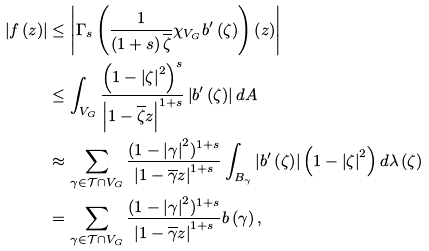<formula> <loc_0><loc_0><loc_500><loc_500>\left | f \left ( z \right ) \right | & \leq \left | \Gamma _ { s } \left ( \frac { 1 } { \left ( 1 + s \right ) \overline { \zeta } } \chi _ { V _ { G } } b ^ { \prime } \left ( \zeta \right ) \right ) \left ( z \right ) \right | \\ & \leq \int _ { V _ { G } } \frac { \left ( 1 - \left | \zeta \right | ^ { 2 } \right ) ^ { s } } { \left | 1 - \overline { \zeta } z \right | ^ { 1 + s } } \left | b ^ { \prime } \left ( \zeta \right ) \right | d A \\ & \approx \sum _ { \gamma \in \mathcal { T } \cap V _ { G } } \frac { ( 1 - \left | \gamma \right | ^ { 2 } ) ^ { 1 + s } } { \left | 1 - \overline { \gamma } z \right | ^ { 1 + s } } \int _ { B _ { \gamma } } \left | b ^ { \prime } \left ( \zeta \right ) \right | \left ( 1 - \left | \zeta \right | ^ { 2 } \right ) d \lambda \left ( \zeta \right ) \\ & = \sum _ { \gamma \in \mathcal { T } \cap V _ { G } } \frac { ( 1 - \left | \gamma \right | ^ { 2 } ) ^ { 1 + s } } { \left | 1 - \overline { \gamma } z \right | ^ { 1 + s } } b \left ( \gamma \right ) ,</formula> 